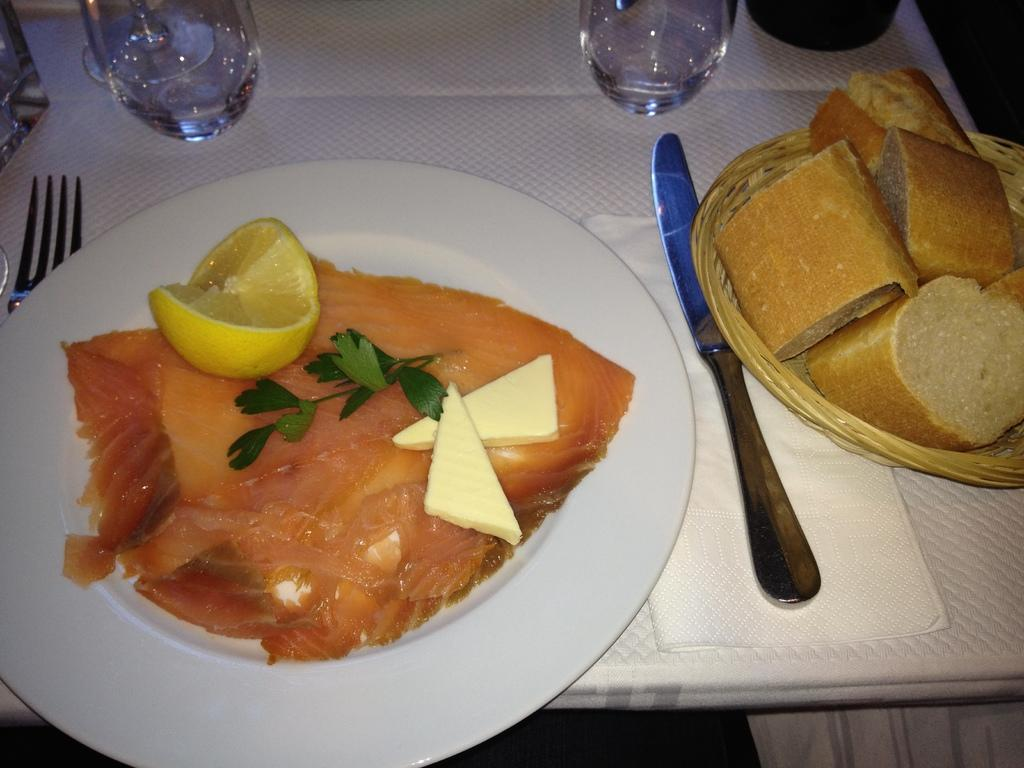What piece of furniture is present in the image? There is a table in the image. What is placed on the table? There is a plate on the table. What is on the plate? There is a food item in the plate. What utensils are beside the plate? There is a knife and a fork beside the plate. How many glasses are in the image? There are two glasses in the image. How does the food item in the plate participate in a fight in the image? The food item in the plate does not participate in a fight in the image; it is simply a food item on a plate. 